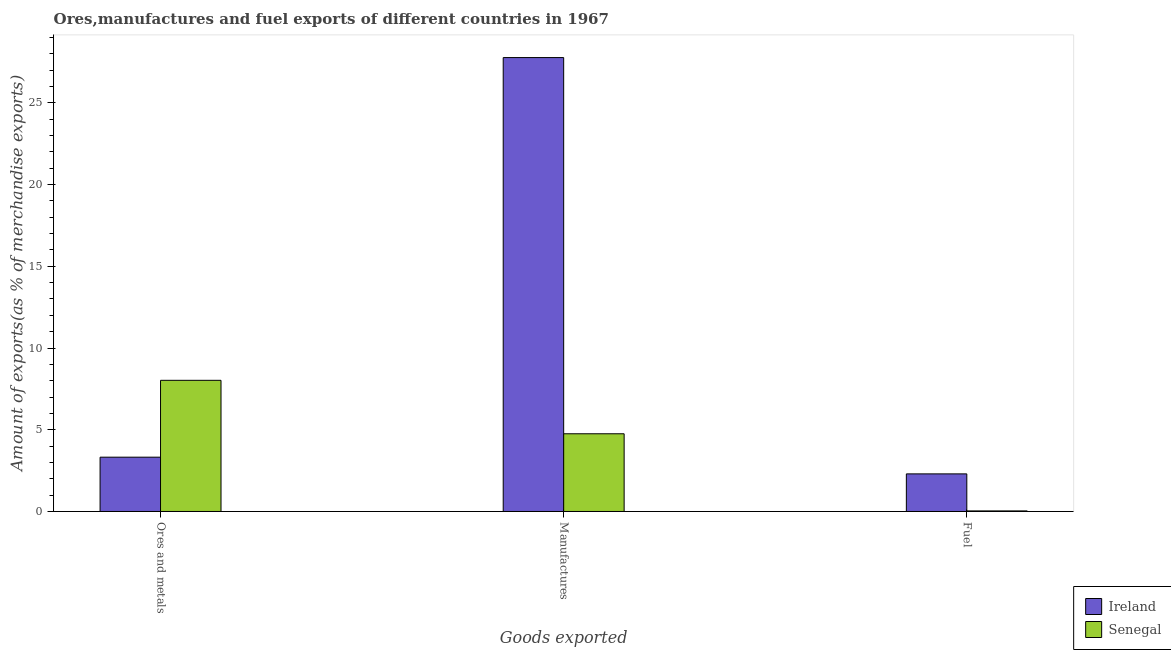How many different coloured bars are there?
Provide a short and direct response. 2. How many groups of bars are there?
Give a very brief answer. 3. Are the number of bars per tick equal to the number of legend labels?
Your answer should be very brief. Yes. Are the number of bars on each tick of the X-axis equal?
Give a very brief answer. Yes. How many bars are there on the 2nd tick from the right?
Your answer should be very brief. 2. What is the label of the 3rd group of bars from the left?
Offer a terse response. Fuel. What is the percentage of fuel exports in Ireland?
Your answer should be compact. 2.3. Across all countries, what is the maximum percentage of ores and metals exports?
Provide a short and direct response. 8.02. Across all countries, what is the minimum percentage of ores and metals exports?
Provide a short and direct response. 3.32. In which country was the percentage of fuel exports maximum?
Make the answer very short. Ireland. In which country was the percentage of ores and metals exports minimum?
Provide a succinct answer. Ireland. What is the total percentage of fuel exports in the graph?
Provide a short and direct response. 2.33. What is the difference between the percentage of fuel exports in Senegal and that in Ireland?
Offer a terse response. -2.27. What is the difference between the percentage of fuel exports in Ireland and the percentage of manufactures exports in Senegal?
Ensure brevity in your answer.  -2.45. What is the average percentage of ores and metals exports per country?
Your answer should be very brief. 5.67. What is the difference between the percentage of fuel exports and percentage of manufactures exports in Senegal?
Offer a very short reply. -4.72. In how many countries, is the percentage of manufactures exports greater than 15 %?
Ensure brevity in your answer.  1. What is the ratio of the percentage of manufactures exports in Ireland to that in Senegal?
Keep it short and to the point. 5.84. Is the percentage of fuel exports in Senegal less than that in Ireland?
Provide a short and direct response. Yes. Is the difference between the percentage of ores and metals exports in Senegal and Ireland greater than the difference between the percentage of fuel exports in Senegal and Ireland?
Ensure brevity in your answer.  Yes. What is the difference between the highest and the second highest percentage of ores and metals exports?
Ensure brevity in your answer.  4.7. What is the difference between the highest and the lowest percentage of manufactures exports?
Your answer should be very brief. 23.01. What does the 1st bar from the left in Fuel represents?
Your response must be concise. Ireland. What does the 2nd bar from the right in Ores and metals represents?
Offer a terse response. Ireland. Is it the case that in every country, the sum of the percentage of ores and metals exports and percentage of manufactures exports is greater than the percentage of fuel exports?
Give a very brief answer. Yes. How many bars are there?
Provide a succinct answer. 6. Are all the bars in the graph horizontal?
Give a very brief answer. No. What is the difference between two consecutive major ticks on the Y-axis?
Keep it short and to the point. 5. Does the graph contain any zero values?
Make the answer very short. No. Does the graph contain grids?
Give a very brief answer. No. How are the legend labels stacked?
Offer a very short reply. Vertical. What is the title of the graph?
Provide a short and direct response. Ores,manufactures and fuel exports of different countries in 1967. What is the label or title of the X-axis?
Ensure brevity in your answer.  Goods exported. What is the label or title of the Y-axis?
Give a very brief answer. Amount of exports(as % of merchandise exports). What is the Amount of exports(as % of merchandise exports) of Ireland in Ores and metals?
Offer a terse response. 3.32. What is the Amount of exports(as % of merchandise exports) in Senegal in Ores and metals?
Your response must be concise. 8.02. What is the Amount of exports(as % of merchandise exports) in Ireland in Manufactures?
Provide a succinct answer. 27.77. What is the Amount of exports(as % of merchandise exports) in Senegal in Manufactures?
Ensure brevity in your answer.  4.75. What is the Amount of exports(as % of merchandise exports) of Ireland in Fuel?
Keep it short and to the point. 2.3. What is the Amount of exports(as % of merchandise exports) in Senegal in Fuel?
Offer a terse response. 0.03. Across all Goods exported, what is the maximum Amount of exports(as % of merchandise exports) of Ireland?
Offer a terse response. 27.77. Across all Goods exported, what is the maximum Amount of exports(as % of merchandise exports) in Senegal?
Provide a short and direct response. 8.02. Across all Goods exported, what is the minimum Amount of exports(as % of merchandise exports) in Ireland?
Offer a terse response. 2.3. Across all Goods exported, what is the minimum Amount of exports(as % of merchandise exports) of Senegal?
Your answer should be compact. 0.03. What is the total Amount of exports(as % of merchandise exports) in Ireland in the graph?
Provide a succinct answer. 33.39. What is the total Amount of exports(as % of merchandise exports) in Senegal in the graph?
Provide a short and direct response. 12.81. What is the difference between the Amount of exports(as % of merchandise exports) of Ireland in Ores and metals and that in Manufactures?
Ensure brevity in your answer.  -24.44. What is the difference between the Amount of exports(as % of merchandise exports) in Senegal in Ores and metals and that in Manufactures?
Offer a terse response. 3.27. What is the difference between the Amount of exports(as % of merchandise exports) of Senegal in Ores and metals and that in Fuel?
Provide a succinct answer. 7.99. What is the difference between the Amount of exports(as % of merchandise exports) of Ireland in Manufactures and that in Fuel?
Keep it short and to the point. 25.47. What is the difference between the Amount of exports(as % of merchandise exports) in Senegal in Manufactures and that in Fuel?
Make the answer very short. 4.72. What is the difference between the Amount of exports(as % of merchandise exports) in Ireland in Ores and metals and the Amount of exports(as % of merchandise exports) in Senegal in Manufactures?
Offer a terse response. -1.43. What is the difference between the Amount of exports(as % of merchandise exports) of Ireland in Ores and metals and the Amount of exports(as % of merchandise exports) of Senegal in Fuel?
Provide a succinct answer. 3.29. What is the difference between the Amount of exports(as % of merchandise exports) in Ireland in Manufactures and the Amount of exports(as % of merchandise exports) in Senegal in Fuel?
Your answer should be very brief. 27.73. What is the average Amount of exports(as % of merchandise exports) of Ireland per Goods exported?
Provide a short and direct response. 11.13. What is the average Amount of exports(as % of merchandise exports) of Senegal per Goods exported?
Your answer should be compact. 4.27. What is the difference between the Amount of exports(as % of merchandise exports) in Ireland and Amount of exports(as % of merchandise exports) in Senegal in Ores and metals?
Ensure brevity in your answer.  -4.7. What is the difference between the Amount of exports(as % of merchandise exports) in Ireland and Amount of exports(as % of merchandise exports) in Senegal in Manufactures?
Your answer should be very brief. 23.01. What is the difference between the Amount of exports(as % of merchandise exports) in Ireland and Amount of exports(as % of merchandise exports) in Senegal in Fuel?
Give a very brief answer. 2.27. What is the ratio of the Amount of exports(as % of merchandise exports) in Ireland in Ores and metals to that in Manufactures?
Your answer should be very brief. 0.12. What is the ratio of the Amount of exports(as % of merchandise exports) of Senegal in Ores and metals to that in Manufactures?
Give a very brief answer. 1.69. What is the ratio of the Amount of exports(as % of merchandise exports) of Ireland in Ores and metals to that in Fuel?
Keep it short and to the point. 1.44. What is the ratio of the Amount of exports(as % of merchandise exports) of Senegal in Ores and metals to that in Fuel?
Your response must be concise. 233.02. What is the ratio of the Amount of exports(as % of merchandise exports) in Ireland in Manufactures to that in Fuel?
Provide a short and direct response. 12.07. What is the ratio of the Amount of exports(as % of merchandise exports) of Senegal in Manufactures to that in Fuel?
Offer a very short reply. 138.07. What is the difference between the highest and the second highest Amount of exports(as % of merchandise exports) in Ireland?
Keep it short and to the point. 24.44. What is the difference between the highest and the second highest Amount of exports(as % of merchandise exports) of Senegal?
Keep it short and to the point. 3.27. What is the difference between the highest and the lowest Amount of exports(as % of merchandise exports) in Ireland?
Your response must be concise. 25.47. What is the difference between the highest and the lowest Amount of exports(as % of merchandise exports) in Senegal?
Provide a short and direct response. 7.99. 